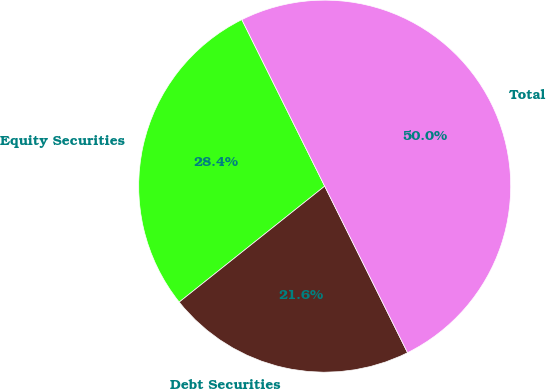Convert chart. <chart><loc_0><loc_0><loc_500><loc_500><pie_chart><fcel>Equity Securities<fcel>Debt Securities<fcel>Total<nl><fcel>28.36%<fcel>21.64%<fcel>50.0%<nl></chart> 